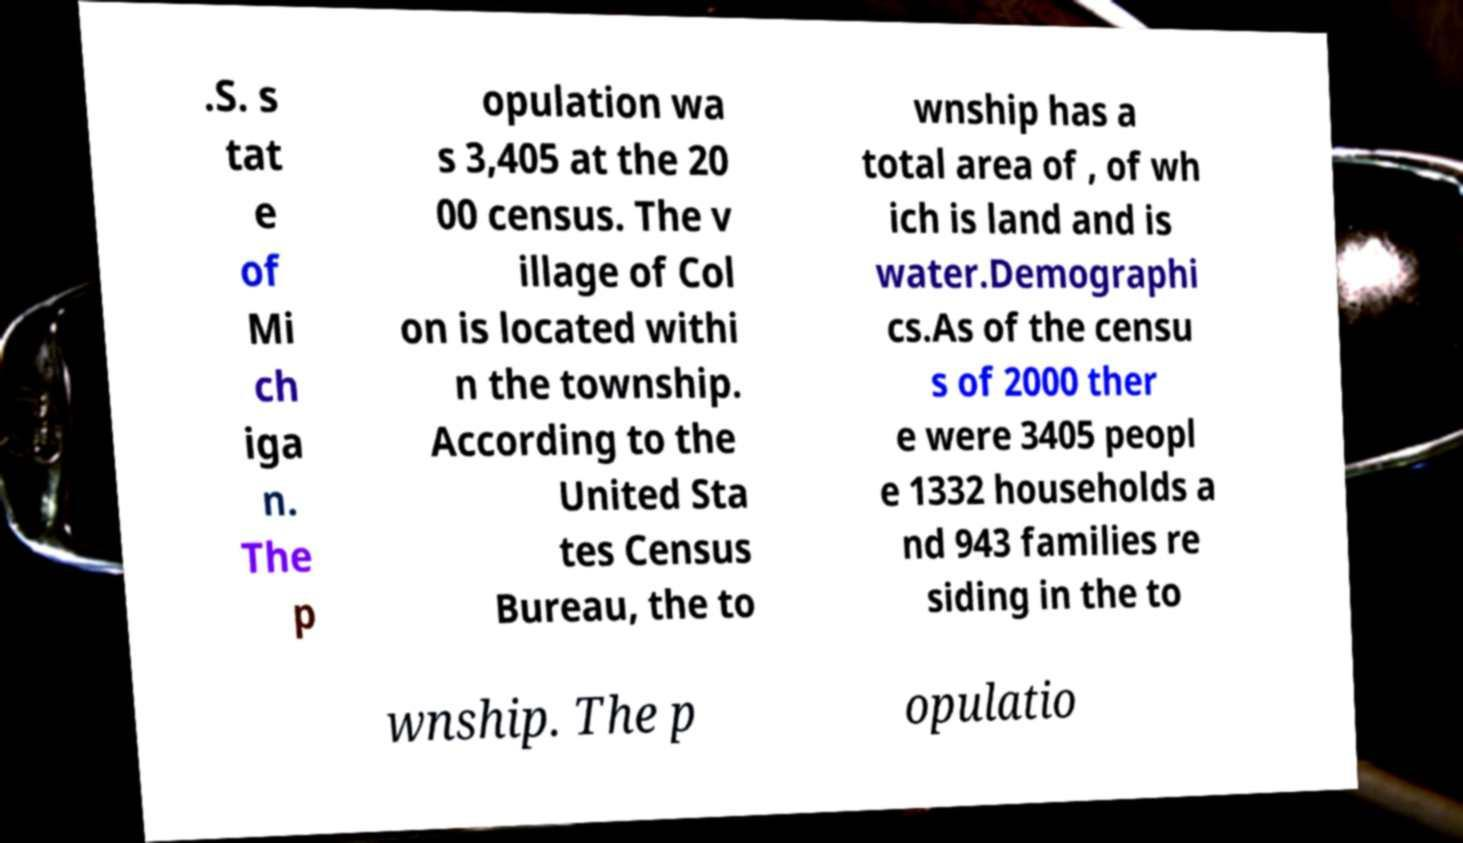Please identify and transcribe the text found in this image. .S. s tat e of Mi ch iga n. The p opulation wa s 3,405 at the 20 00 census. The v illage of Col on is located withi n the township. According to the United Sta tes Census Bureau, the to wnship has a total area of , of wh ich is land and is water.Demographi cs.As of the censu s of 2000 ther e were 3405 peopl e 1332 households a nd 943 families re siding in the to wnship. The p opulatio 